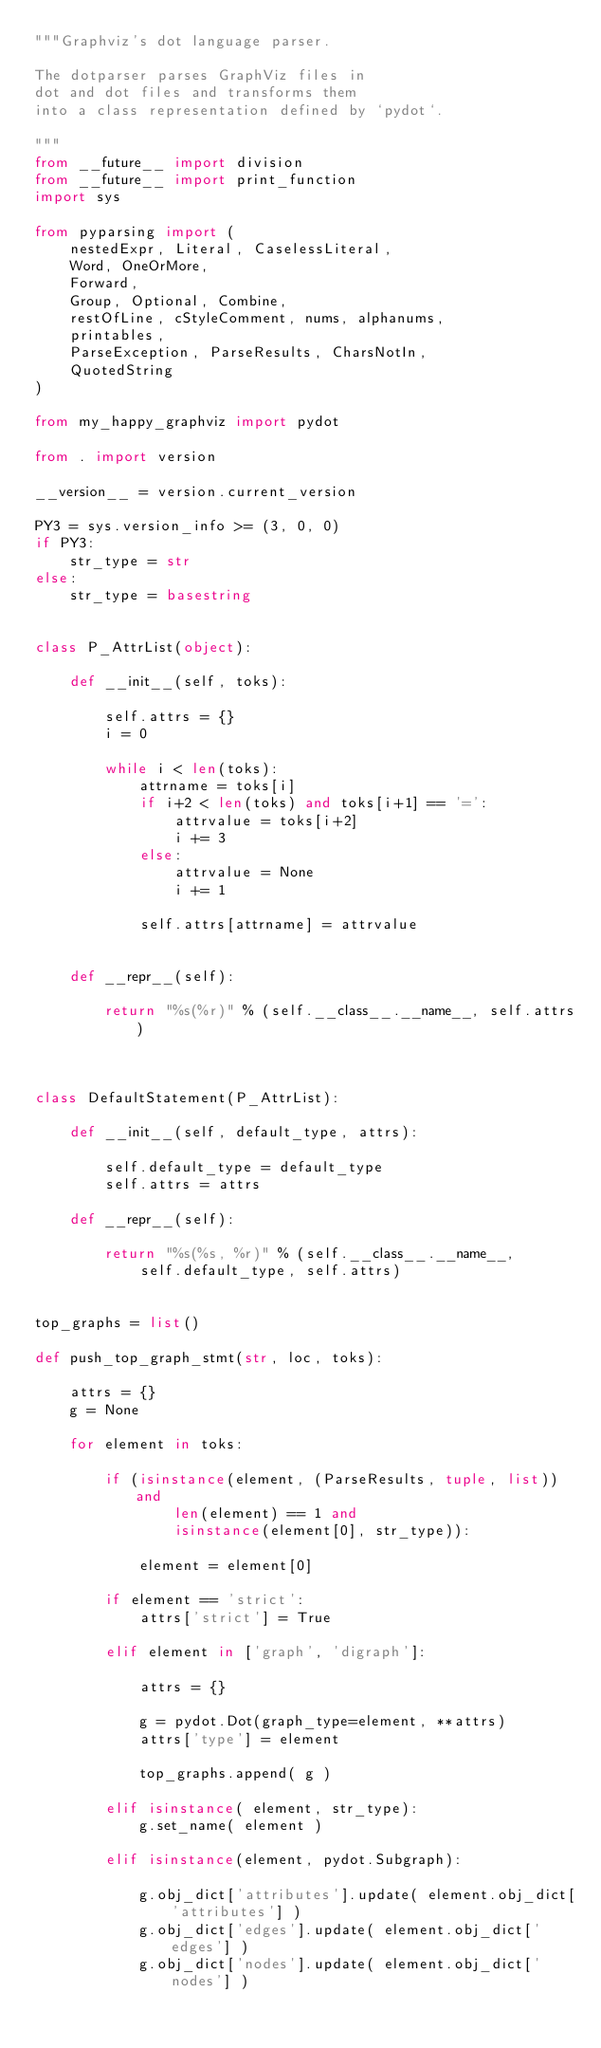Convert code to text. <code><loc_0><loc_0><loc_500><loc_500><_Python_>"""Graphviz's dot language parser.

The dotparser parses GraphViz files in
dot and dot files and transforms them
into a class representation defined by `pydot`.

"""
from __future__ import division
from __future__ import print_function
import sys

from pyparsing import (
    nestedExpr, Literal, CaselessLiteral,
    Word, OneOrMore,
    Forward,
    Group, Optional, Combine,
    restOfLine, cStyleComment, nums, alphanums,
    printables,
    ParseException, ParseResults, CharsNotIn,
    QuotedString
)

from my_happy_graphviz import pydot

from . import version

__version__ = version.current_version

PY3 = sys.version_info >= (3, 0, 0)
if PY3:
    str_type = str
else:
    str_type = basestring


class P_AttrList(object):

    def __init__(self, toks):

        self.attrs = {}
        i = 0

        while i < len(toks):
            attrname = toks[i]
            if i+2 < len(toks) and toks[i+1] == '=':
                attrvalue = toks[i+2]
                i += 3
            else:
                attrvalue = None
                i += 1

            self.attrs[attrname] = attrvalue


    def __repr__(self):

        return "%s(%r)" % (self.__class__.__name__, self.attrs)



class DefaultStatement(P_AttrList):

    def __init__(self, default_type, attrs):

        self.default_type = default_type
        self.attrs = attrs

    def __repr__(self):

        return "%s(%s, %r)" % (self.__class__.__name__,
            self.default_type, self.attrs)


top_graphs = list()

def push_top_graph_stmt(str, loc, toks):

    attrs = {}
    g = None

    for element in toks:

        if (isinstance(element, (ParseResults, tuple, list)) and
                len(element) == 1 and
                isinstance(element[0], str_type)):

            element = element[0]

        if element == 'strict':
            attrs['strict'] = True

        elif element in ['graph', 'digraph']:

            attrs = {}

            g = pydot.Dot(graph_type=element, **attrs)
            attrs['type'] = element

            top_graphs.append( g )

        elif isinstance( element, str_type):
            g.set_name( element )

        elif isinstance(element, pydot.Subgraph):

            g.obj_dict['attributes'].update( element.obj_dict['attributes'] )
            g.obj_dict['edges'].update( element.obj_dict['edges'] )
            g.obj_dict['nodes'].update( element.obj_dict['nodes'] )</code> 